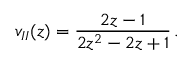<formula> <loc_0><loc_0><loc_500><loc_500>v _ { I I } ( z ) = { \frac { 2 z - 1 } { 2 z ^ { 2 } - 2 z + 1 } } \, .</formula> 